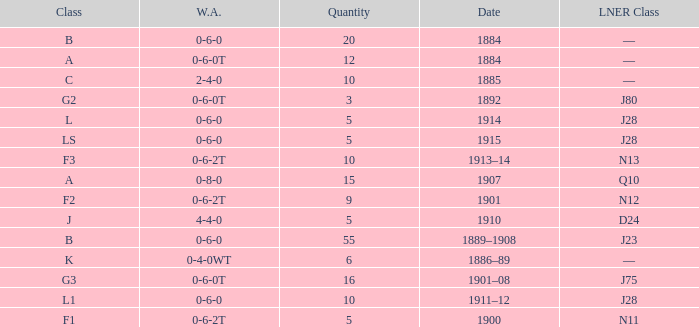What class is associated with a W.A. of 0-8-0? A. 